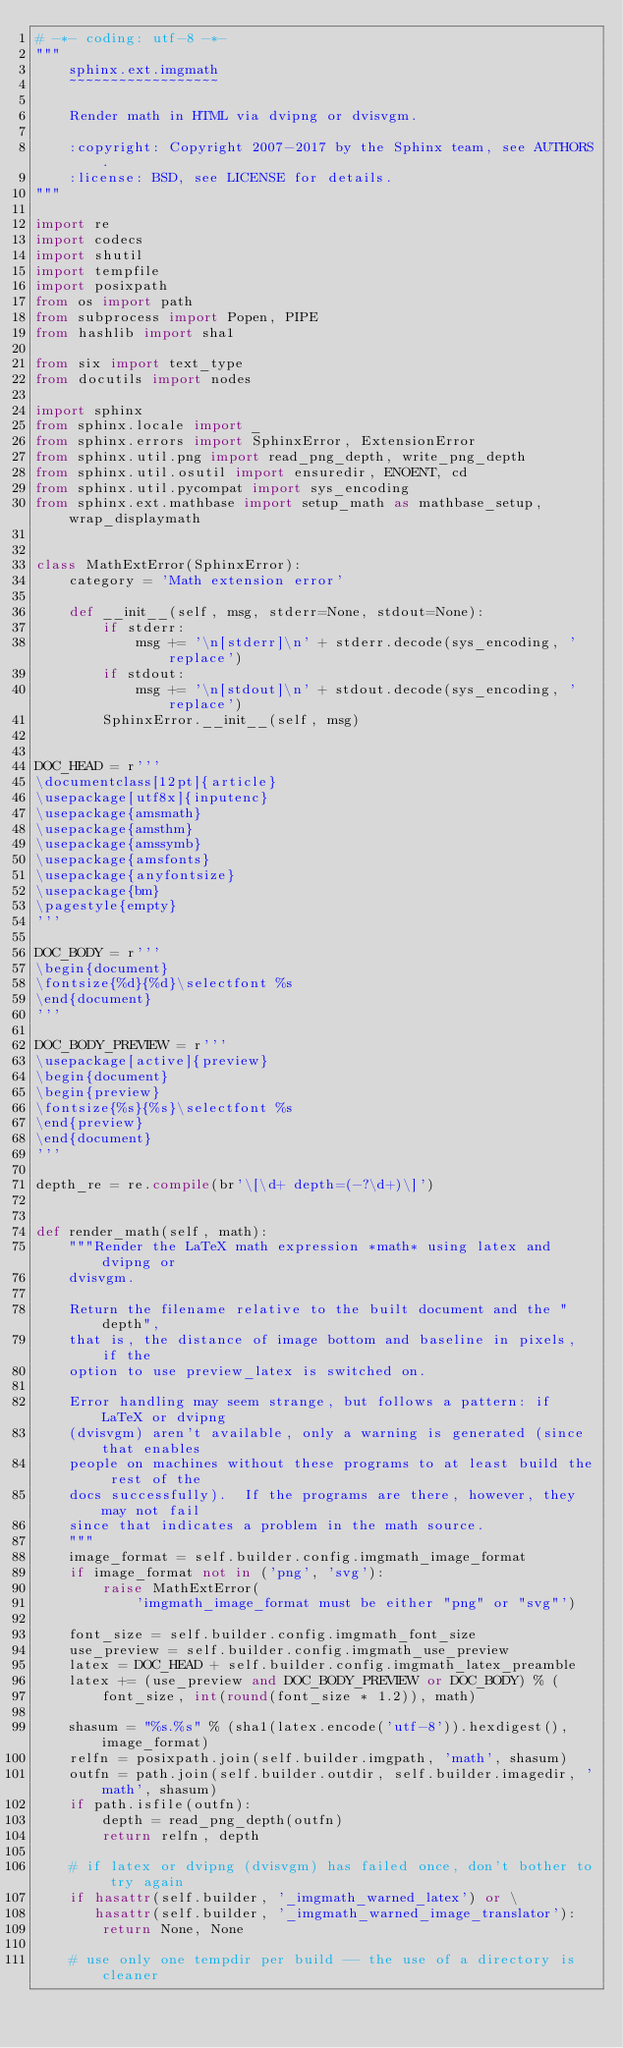Convert code to text. <code><loc_0><loc_0><loc_500><loc_500><_Python_># -*- coding: utf-8 -*-
"""
    sphinx.ext.imgmath
    ~~~~~~~~~~~~~~~~~~

    Render math in HTML via dvipng or dvisvgm.

    :copyright: Copyright 2007-2017 by the Sphinx team, see AUTHORS.
    :license: BSD, see LICENSE for details.
"""

import re
import codecs
import shutil
import tempfile
import posixpath
from os import path
from subprocess import Popen, PIPE
from hashlib import sha1

from six import text_type
from docutils import nodes

import sphinx
from sphinx.locale import _
from sphinx.errors import SphinxError, ExtensionError
from sphinx.util.png import read_png_depth, write_png_depth
from sphinx.util.osutil import ensuredir, ENOENT, cd
from sphinx.util.pycompat import sys_encoding
from sphinx.ext.mathbase import setup_math as mathbase_setup, wrap_displaymath


class MathExtError(SphinxError):
    category = 'Math extension error'

    def __init__(self, msg, stderr=None, stdout=None):
        if stderr:
            msg += '\n[stderr]\n' + stderr.decode(sys_encoding, 'replace')
        if stdout:
            msg += '\n[stdout]\n' + stdout.decode(sys_encoding, 'replace')
        SphinxError.__init__(self, msg)


DOC_HEAD = r'''
\documentclass[12pt]{article}
\usepackage[utf8x]{inputenc}
\usepackage{amsmath}
\usepackage{amsthm}
\usepackage{amssymb}
\usepackage{amsfonts}
\usepackage{anyfontsize}
\usepackage{bm}
\pagestyle{empty}
'''

DOC_BODY = r'''
\begin{document}
\fontsize{%d}{%d}\selectfont %s
\end{document}
'''

DOC_BODY_PREVIEW = r'''
\usepackage[active]{preview}
\begin{document}
\begin{preview}
\fontsize{%s}{%s}\selectfont %s
\end{preview}
\end{document}
'''

depth_re = re.compile(br'\[\d+ depth=(-?\d+)\]')


def render_math(self, math):
    """Render the LaTeX math expression *math* using latex and dvipng or
    dvisvgm.

    Return the filename relative to the built document and the "depth",
    that is, the distance of image bottom and baseline in pixels, if the
    option to use preview_latex is switched on.

    Error handling may seem strange, but follows a pattern: if LaTeX or dvipng
    (dvisvgm) aren't available, only a warning is generated (since that enables
    people on machines without these programs to at least build the rest of the
    docs successfully).  If the programs are there, however, they may not fail
    since that indicates a problem in the math source.
    """
    image_format = self.builder.config.imgmath_image_format
    if image_format not in ('png', 'svg'):
        raise MathExtError(
            'imgmath_image_format must be either "png" or "svg"')

    font_size = self.builder.config.imgmath_font_size
    use_preview = self.builder.config.imgmath_use_preview
    latex = DOC_HEAD + self.builder.config.imgmath_latex_preamble
    latex += (use_preview and DOC_BODY_PREVIEW or DOC_BODY) % (
        font_size, int(round(font_size * 1.2)), math)

    shasum = "%s.%s" % (sha1(latex.encode('utf-8')).hexdigest(), image_format)
    relfn = posixpath.join(self.builder.imgpath, 'math', shasum)
    outfn = path.join(self.builder.outdir, self.builder.imagedir, 'math', shasum)
    if path.isfile(outfn):
        depth = read_png_depth(outfn)
        return relfn, depth

    # if latex or dvipng (dvisvgm) has failed once, don't bother to try again
    if hasattr(self.builder, '_imgmath_warned_latex') or \
       hasattr(self.builder, '_imgmath_warned_image_translator'):
        return None, None

    # use only one tempdir per build -- the use of a directory is cleaner</code> 